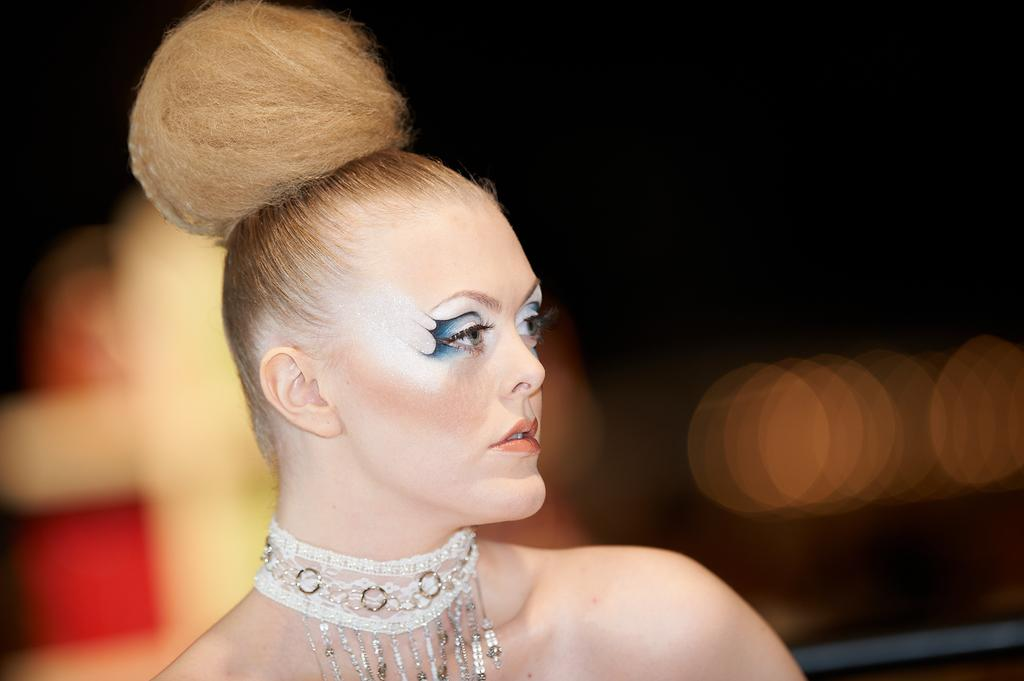Who is present in the image? There is a woman in the image. What is the woman wearing? The woman is wearing ornaments. Can you describe the background of the image? The background of the image is dark and blurry. What color of paint is being used on the hydrant in the image? There is no hydrant present in the image, so it is not possible to determine the color of paint being used. 